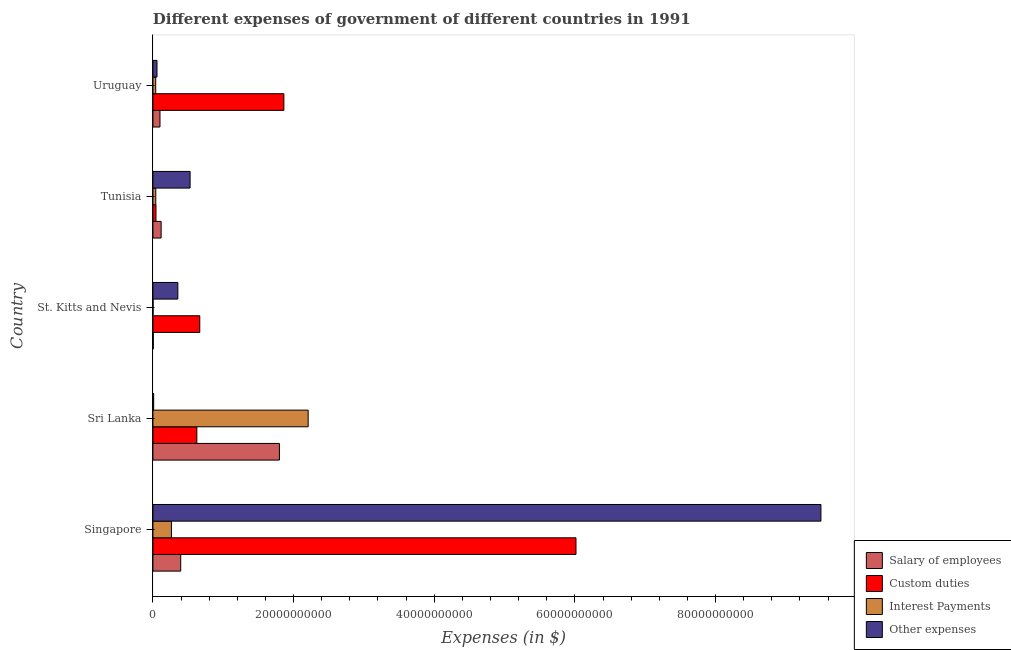How many different coloured bars are there?
Your answer should be very brief. 4. Are the number of bars on each tick of the Y-axis equal?
Your response must be concise. Yes. How many bars are there on the 3rd tick from the top?
Offer a very short reply. 4. How many bars are there on the 3rd tick from the bottom?
Your answer should be compact. 4. What is the label of the 5th group of bars from the top?
Give a very brief answer. Singapore. What is the amount spent on other expenses in St. Kitts and Nevis?
Provide a succinct answer. 3.54e+09. Across all countries, what is the maximum amount spent on custom duties?
Give a very brief answer. 6.02e+1. Across all countries, what is the minimum amount spent on other expenses?
Your answer should be very brief. 1.02e+08. In which country was the amount spent on interest payments maximum?
Offer a very short reply. Sri Lanka. In which country was the amount spent on custom duties minimum?
Your response must be concise. Tunisia. What is the total amount spent on other expenses in the graph?
Offer a very short reply. 1.04e+11. What is the difference between the amount spent on custom duties in Singapore and that in Tunisia?
Your answer should be very brief. 5.97e+1. What is the difference between the amount spent on other expenses in Sri Lanka and the amount spent on salary of employees in Uruguay?
Offer a terse response. -8.99e+08. What is the average amount spent on interest payments per country?
Your answer should be compact. 5.10e+09. What is the difference between the amount spent on custom duties and amount spent on salary of employees in St. Kitts and Nevis?
Offer a very short reply. 6.61e+09. What is the ratio of the amount spent on interest payments in St. Kitts and Nevis to that in Uruguay?
Your answer should be very brief. 0.04. What is the difference between the highest and the second highest amount spent on custom duties?
Your response must be concise. 4.15e+1. What is the difference between the highest and the lowest amount spent on custom duties?
Keep it short and to the point. 5.97e+1. Is the sum of the amount spent on other expenses in Tunisia and Uruguay greater than the maximum amount spent on custom duties across all countries?
Make the answer very short. No. Is it the case that in every country, the sum of the amount spent on custom duties and amount spent on other expenses is greater than the sum of amount spent on interest payments and amount spent on salary of employees?
Your answer should be very brief. No. What does the 2nd bar from the top in St. Kitts and Nevis represents?
Ensure brevity in your answer.  Interest Payments. What does the 3rd bar from the bottom in Tunisia represents?
Provide a short and direct response. Interest Payments. Is it the case that in every country, the sum of the amount spent on salary of employees and amount spent on custom duties is greater than the amount spent on interest payments?
Offer a terse response. Yes. How many countries are there in the graph?
Provide a short and direct response. 5. Does the graph contain grids?
Your answer should be compact. No. How many legend labels are there?
Provide a short and direct response. 4. What is the title of the graph?
Ensure brevity in your answer.  Different expenses of government of different countries in 1991. Does "Korea" appear as one of the legend labels in the graph?
Give a very brief answer. No. What is the label or title of the X-axis?
Provide a succinct answer. Expenses (in $). What is the label or title of the Y-axis?
Your answer should be very brief. Country. What is the Expenses (in $) of Salary of employees in Singapore?
Your answer should be compact. 3.95e+09. What is the Expenses (in $) of Custom duties in Singapore?
Your response must be concise. 6.02e+1. What is the Expenses (in $) in Interest Payments in Singapore?
Provide a succinct answer. 2.63e+09. What is the Expenses (in $) in Other expenses in Singapore?
Offer a very short reply. 9.50e+1. What is the Expenses (in $) in Salary of employees in Sri Lanka?
Your response must be concise. 1.80e+1. What is the Expenses (in $) of Custom duties in Sri Lanka?
Offer a terse response. 6.24e+09. What is the Expenses (in $) in Interest Payments in Sri Lanka?
Give a very brief answer. 2.21e+1. What is the Expenses (in $) of Other expenses in Sri Lanka?
Your answer should be compact. 1.02e+08. What is the Expenses (in $) of Salary of employees in St. Kitts and Nevis?
Your answer should be compact. 5.13e+07. What is the Expenses (in $) in Custom duties in St. Kitts and Nevis?
Make the answer very short. 6.66e+09. What is the Expenses (in $) in Interest Payments in St. Kitts and Nevis?
Ensure brevity in your answer.  1.40e+07. What is the Expenses (in $) in Other expenses in St. Kitts and Nevis?
Your response must be concise. 3.54e+09. What is the Expenses (in $) of Salary of employees in Tunisia?
Your answer should be compact. 1.16e+09. What is the Expenses (in $) of Custom duties in Tunisia?
Your answer should be very brief. 4.33e+08. What is the Expenses (in $) of Interest Payments in Tunisia?
Give a very brief answer. 4.05e+08. What is the Expenses (in $) in Other expenses in Tunisia?
Make the answer very short. 5.28e+09. What is the Expenses (in $) in Salary of employees in Uruguay?
Make the answer very short. 1.00e+09. What is the Expenses (in $) of Custom duties in Uruguay?
Ensure brevity in your answer.  1.86e+1. What is the Expenses (in $) in Interest Payments in Uruguay?
Provide a succinct answer. 3.95e+08. What is the Expenses (in $) of Other expenses in Uruguay?
Provide a short and direct response. 5.77e+08. Across all countries, what is the maximum Expenses (in $) of Salary of employees?
Offer a very short reply. 1.80e+1. Across all countries, what is the maximum Expenses (in $) in Custom duties?
Keep it short and to the point. 6.02e+1. Across all countries, what is the maximum Expenses (in $) of Interest Payments?
Your response must be concise. 2.21e+1. Across all countries, what is the maximum Expenses (in $) of Other expenses?
Make the answer very short. 9.50e+1. Across all countries, what is the minimum Expenses (in $) of Salary of employees?
Make the answer very short. 5.13e+07. Across all countries, what is the minimum Expenses (in $) of Custom duties?
Give a very brief answer. 4.33e+08. Across all countries, what is the minimum Expenses (in $) in Interest Payments?
Make the answer very short. 1.40e+07. Across all countries, what is the minimum Expenses (in $) in Other expenses?
Keep it short and to the point. 1.02e+08. What is the total Expenses (in $) of Salary of employees in the graph?
Your answer should be very brief. 2.42e+1. What is the total Expenses (in $) of Custom duties in the graph?
Your answer should be very brief. 9.21e+1. What is the total Expenses (in $) of Interest Payments in the graph?
Offer a very short reply. 2.55e+1. What is the total Expenses (in $) of Other expenses in the graph?
Provide a succinct answer. 1.04e+11. What is the difference between the Expenses (in $) in Salary of employees in Singapore and that in Sri Lanka?
Your answer should be compact. -1.40e+1. What is the difference between the Expenses (in $) in Custom duties in Singapore and that in Sri Lanka?
Give a very brief answer. 5.39e+1. What is the difference between the Expenses (in $) in Interest Payments in Singapore and that in Sri Lanka?
Keep it short and to the point. -1.94e+1. What is the difference between the Expenses (in $) in Other expenses in Singapore and that in Sri Lanka?
Give a very brief answer. 9.49e+1. What is the difference between the Expenses (in $) of Salary of employees in Singapore and that in St. Kitts and Nevis?
Provide a short and direct response. 3.90e+09. What is the difference between the Expenses (in $) of Custom duties in Singapore and that in St. Kitts and Nevis?
Your answer should be compact. 5.35e+1. What is the difference between the Expenses (in $) of Interest Payments in Singapore and that in St. Kitts and Nevis?
Give a very brief answer. 2.62e+09. What is the difference between the Expenses (in $) of Other expenses in Singapore and that in St. Kitts and Nevis?
Make the answer very short. 9.14e+1. What is the difference between the Expenses (in $) in Salary of employees in Singapore and that in Tunisia?
Your response must be concise. 2.78e+09. What is the difference between the Expenses (in $) of Custom duties in Singapore and that in Tunisia?
Provide a short and direct response. 5.97e+1. What is the difference between the Expenses (in $) in Interest Payments in Singapore and that in Tunisia?
Provide a short and direct response. 2.22e+09. What is the difference between the Expenses (in $) of Other expenses in Singapore and that in Tunisia?
Offer a terse response. 8.97e+1. What is the difference between the Expenses (in $) in Salary of employees in Singapore and that in Uruguay?
Keep it short and to the point. 2.95e+09. What is the difference between the Expenses (in $) in Custom duties in Singapore and that in Uruguay?
Your answer should be compact. 4.15e+1. What is the difference between the Expenses (in $) in Interest Payments in Singapore and that in Uruguay?
Offer a terse response. 2.23e+09. What is the difference between the Expenses (in $) in Other expenses in Singapore and that in Uruguay?
Offer a very short reply. 9.44e+1. What is the difference between the Expenses (in $) in Salary of employees in Sri Lanka and that in St. Kitts and Nevis?
Give a very brief answer. 1.79e+1. What is the difference between the Expenses (in $) of Custom duties in Sri Lanka and that in St. Kitts and Nevis?
Offer a very short reply. -4.14e+08. What is the difference between the Expenses (in $) of Interest Payments in Sri Lanka and that in St. Kitts and Nevis?
Your answer should be very brief. 2.21e+1. What is the difference between the Expenses (in $) in Other expenses in Sri Lanka and that in St. Kitts and Nevis?
Offer a very short reply. -3.44e+09. What is the difference between the Expenses (in $) of Salary of employees in Sri Lanka and that in Tunisia?
Offer a terse response. 1.68e+1. What is the difference between the Expenses (in $) in Custom duties in Sri Lanka and that in Tunisia?
Give a very brief answer. 5.81e+09. What is the difference between the Expenses (in $) of Interest Payments in Sri Lanka and that in Tunisia?
Give a very brief answer. 2.17e+1. What is the difference between the Expenses (in $) of Other expenses in Sri Lanka and that in Tunisia?
Offer a very short reply. -5.18e+09. What is the difference between the Expenses (in $) in Salary of employees in Sri Lanka and that in Uruguay?
Keep it short and to the point. 1.70e+1. What is the difference between the Expenses (in $) in Custom duties in Sri Lanka and that in Uruguay?
Your response must be concise. -1.24e+1. What is the difference between the Expenses (in $) in Interest Payments in Sri Lanka and that in Uruguay?
Your answer should be very brief. 2.17e+1. What is the difference between the Expenses (in $) in Other expenses in Sri Lanka and that in Uruguay?
Ensure brevity in your answer.  -4.75e+08. What is the difference between the Expenses (in $) of Salary of employees in St. Kitts and Nevis and that in Tunisia?
Provide a succinct answer. -1.11e+09. What is the difference between the Expenses (in $) in Custom duties in St. Kitts and Nevis and that in Tunisia?
Your response must be concise. 6.22e+09. What is the difference between the Expenses (in $) in Interest Payments in St. Kitts and Nevis and that in Tunisia?
Your answer should be compact. -3.91e+08. What is the difference between the Expenses (in $) of Other expenses in St. Kitts and Nevis and that in Tunisia?
Your answer should be very brief. -1.74e+09. What is the difference between the Expenses (in $) of Salary of employees in St. Kitts and Nevis and that in Uruguay?
Keep it short and to the point. -9.50e+08. What is the difference between the Expenses (in $) in Custom duties in St. Kitts and Nevis and that in Uruguay?
Provide a short and direct response. -1.20e+1. What is the difference between the Expenses (in $) in Interest Payments in St. Kitts and Nevis and that in Uruguay?
Give a very brief answer. -3.81e+08. What is the difference between the Expenses (in $) in Other expenses in St. Kitts and Nevis and that in Uruguay?
Keep it short and to the point. 2.96e+09. What is the difference between the Expenses (in $) of Salary of employees in Tunisia and that in Uruguay?
Make the answer very short. 1.64e+08. What is the difference between the Expenses (in $) of Custom duties in Tunisia and that in Uruguay?
Ensure brevity in your answer.  -1.82e+1. What is the difference between the Expenses (in $) in Interest Payments in Tunisia and that in Uruguay?
Your answer should be compact. 1.00e+07. What is the difference between the Expenses (in $) of Other expenses in Tunisia and that in Uruguay?
Your response must be concise. 4.70e+09. What is the difference between the Expenses (in $) of Salary of employees in Singapore and the Expenses (in $) of Custom duties in Sri Lanka?
Your answer should be very brief. -2.29e+09. What is the difference between the Expenses (in $) in Salary of employees in Singapore and the Expenses (in $) in Interest Payments in Sri Lanka?
Give a very brief answer. -1.81e+1. What is the difference between the Expenses (in $) in Salary of employees in Singapore and the Expenses (in $) in Other expenses in Sri Lanka?
Your answer should be compact. 3.85e+09. What is the difference between the Expenses (in $) of Custom duties in Singapore and the Expenses (in $) of Interest Payments in Sri Lanka?
Your answer should be compact. 3.81e+1. What is the difference between the Expenses (in $) of Custom duties in Singapore and the Expenses (in $) of Other expenses in Sri Lanka?
Offer a terse response. 6.01e+1. What is the difference between the Expenses (in $) in Interest Payments in Singapore and the Expenses (in $) in Other expenses in Sri Lanka?
Your answer should be very brief. 2.53e+09. What is the difference between the Expenses (in $) in Salary of employees in Singapore and the Expenses (in $) in Custom duties in St. Kitts and Nevis?
Provide a short and direct response. -2.71e+09. What is the difference between the Expenses (in $) of Salary of employees in Singapore and the Expenses (in $) of Interest Payments in St. Kitts and Nevis?
Provide a succinct answer. 3.94e+09. What is the difference between the Expenses (in $) of Salary of employees in Singapore and the Expenses (in $) of Other expenses in St. Kitts and Nevis?
Your response must be concise. 4.08e+08. What is the difference between the Expenses (in $) of Custom duties in Singapore and the Expenses (in $) of Interest Payments in St. Kitts and Nevis?
Offer a very short reply. 6.01e+1. What is the difference between the Expenses (in $) in Custom duties in Singapore and the Expenses (in $) in Other expenses in St. Kitts and Nevis?
Ensure brevity in your answer.  5.66e+1. What is the difference between the Expenses (in $) in Interest Payments in Singapore and the Expenses (in $) in Other expenses in St. Kitts and Nevis?
Keep it short and to the point. -9.12e+08. What is the difference between the Expenses (in $) in Salary of employees in Singapore and the Expenses (in $) in Custom duties in Tunisia?
Your answer should be very brief. 3.52e+09. What is the difference between the Expenses (in $) of Salary of employees in Singapore and the Expenses (in $) of Interest Payments in Tunisia?
Provide a short and direct response. 3.54e+09. What is the difference between the Expenses (in $) in Salary of employees in Singapore and the Expenses (in $) in Other expenses in Tunisia?
Make the answer very short. -1.33e+09. What is the difference between the Expenses (in $) of Custom duties in Singapore and the Expenses (in $) of Interest Payments in Tunisia?
Provide a short and direct response. 5.98e+1. What is the difference between the Expenses (in $) of Custom duties in Singapore and the Expenses (in $) of Other expenses in Tunisia?
Provide a succinct answer. 5.49e+1. What is the difference between the Expenses (in $) in Interest Payments in Singapore and the Expenses (in $) in Other expenses in Tunisia?
Make the answer very short. -2.65e+09. What is the difference between the Expenses (in $) in Salary of employees in Singapore and the Expenses (in $) in Custom duties in Uruguay?
Ensure brevity in your answer.  -1.47e+1. What is the difference between the Expenses (in $) in Salary of employees in Singapore and the Expenses (in $) in Interest Payments in Uruguay?
Provide a succinct answer. 3.55e+09. What is the difference between the Expenses (in $) of Salary of employees in Singapore and the Expenses (in $) of Other expenses in Uruguay?
Give a very brief answer. 3.37e+09. What is the difference between the Expenses (in $) in Custom duties in Singapore and the Expenses (in $) in Interest Payments in Uruguay?
Give a very brief answer. 5.98e+1. What is the difference between the Expenses (in $) in Custom duties in Singapore and the Expenses (in $) in Other expenses in Uruguay?
Give a very brief answer. 5.96e+1. What is the difference between the Expenses (in $) of Interest Payments in Singapore and the Expenses (in $) of Other expenses in Uruguay?
Provide a short and direct response. 2.05e+09. What is the difference between the Expenses (in $) in Salary of employees in Sri Lanka and the Expenses (in $) in Custom duties in St. Kitts and Nevis?
Your answer should be very brief. 1.13e+1. What is the difference between the Expenses (in $) of Salary of employees in Sri Lanka and the Expenses (in $) of Interest Payments in St. Kitts and Nevis?
Your response must be concise. 1.80e+1. What is the difference between the Expenses (in $) in Salary of employees in Sri Lanka and the Expenses (in $) in Other expenses in St. Kitts and Nevis?
Offer a very short reply. 1.44e+1. What is the difference between the Expenses (in $) in Custom duties in Sri Lanka and the Expenses (in $) in Interest Payments in St. Kitts and Nevis?
Your answer should be very brief. 6.23e+09. What is the difference between the Expenses (in $) of Custom duties in Sri Lanka and the Expenses (in $) of Other expenses in St. Kitts and Nevis?
Give a very brief answer. 2.70e+09. What is the difference between the Expenses (in $) of Interest Payments in Sri Lanka and the Expenses (in $) of Other expenses in St. Kitts and Nevis?
Offer a very short reply. 1.85e+1. What is the difference between the Expenses (in $) of Salary of employees in Sri Lanka and the Expenses (in $) of Custom duties in Tunisia?
Ensure brevity in your answer.  1.76e+1. What is the difference between the Expenses (in $) of Salary of employees in Sri Lanka and the Expenses (in $) of Interest Payments in Tunisia?
Make the answer very short. 1.76e+1. What is the difference between the Expenses (in $) of Salary of employees in Sri Lanka and the Expenses (in $) of Other expenses in Tunisia?
Offer a terse response. 1.27e+1. What is the difference between the Expenses (in $) of Custom duties in Sri Lanka and the Expenses (in $) of Interest Payments in Tunisia?
Give a very brief answer. 5.84e+09. What is the difference between the Expenses (in $) of Custom duties in Sri Lanka and the Expenses (in $) of Other expenses in Tunisia?
Provide a succinct answer. 9.61e+08. What is the difference between the Expenses (in $) of Interest Payments in Sri Lanka and the Expenses (in $) of Other expenses in Tunisia?
Provide a succinct answer. 1.68e+1. What is the difference between the Expenses (in $) of Salary of employees in Sri Lanka and the Expenses (in $) of Custom duties in Uruguay?
Keep it short and to the point. -6.32e+08. What is the difference between the Expenses (in $) of Salary of employees in Sri Lanka and the Expenses (in $) of Interest Payments in Uruguay?
Provide a succinct answer. 1.76e+1. What is the difference between the Expenses (in $) in Salary of employees in Sri Lanka and the Expenses (in $) in Other expenses in Uruguay?
Offer a terse response. 1.74e+1. What is the difference between the Expenses (in $) in Custom duties in Sri Lanka and the Expenses (in $) in Interest Payments in Uruguay?
Give a very brief answer. 5.85e+09. What is the difference between the Expenses (in $) of Custom duties in Sri Lanka and the Expenses (in $) of Other expenses in Uruguay?
Provide a succinct answer. 5.67e+09. What is the difference between the Expenses (in $) in Interest Payments in Sri Lanka and the Expenses (in $) in Other expenses in Uruguay?
Provide a short and direct response. 2.15e+1. What is the difference between the Expenses (in $) in Salary of employees in St. Kitts and Nevis and the Expenses (in $) in Custom duties in Tunisia?
Keep it short and to the point. -3.82e+08. What is the difference between the Expenses (in $) in Salary of employees in St. Kitts and Nevis and the Expenses (in $) in Interest Payments in Tunisia?
Offer a terse response. -3.54e+08. What is the difference between the Expenses (in $) of Salary of employees in St. Kitts and Nevis and the Expenses (in $) of Other expenses in Tunisia?
Your answer should be very brief. -5.23e+09. What is the difference between the Expenses (in $) of Custom duties in St. Kitts and Nevis and the Expenses (in $) of Interest Payments in Tunisia?
Your answer should be very brief. 6.25e+09. What is the difference between the Expenses (in $) in Custom duties in St. Kitts and Nevis and the Expenses (in $) in Other expenses in Tunisia?
Your response must be concise. 1.38e+09. What is the difference between the Expenses (in $) in Interest Payments in St. Kitts and Nevis and the Expenses (in $) in Other expenses in Tunisia?
Provide a succinct answer. -5.27e+09. What is the difference between the Expenses (in $) of Salary of employees in St. Kitts and Nevis and the Expenses (in $) of Custom duties in Uruguay?
Offer a terse response. -1.86e+1. What is the difference between the Expenses (in $) in Salary of employees in St. Kitts and Nevis and the Expenses (in $) in Interest Payments in Uruguay?
Make the answer very short. -3.44e+08. What is the difference between the Expenses (in $) of Salary of employees in St. Kitts and Nevis and the Expenses (in $) of Other expenses in Uruguay?
Offer a very short reply. -5.26e+08. What is the difference between the Expenses (in $) of Custom duties in St. Kitts and Nevis and the Expenses (in $) of Interest Payments in Uruguay?
Ensure brevity in your answer.  6.26e+09. What is the difference between the Expenses (in $) in Custom duties in St. Kitts and Nevis and the Expenses (in $) in Other expenses in Uruguay?
Give a very brief answer. 6.08e+09. What is the difference between the Expenses (in $) of Interest Payments in St. Kitts and Nevis and the Expenses (in $) of Other expenses in Uruguay?
Your answer should be very brief. -5.63e+08. What is the difference between the Expenses (in $) of Salary of employees in Tunisia and the Expenses (in $) of Custom duties in Uruguay?
Ensure brevity in your answer.  -1.75e+1. What is the difference between the Expenses (in $) of Salary of employees in Tunisia and the Expenses (in $) of Interest Payments in Uruguay?
Your answer should be compact. 7.70e+08. What is the difference between the Expenses (in $) in Salary of employees in Tunisia and the Expenses (in $) in Other expenses in Uruguay?
Keep it short and to the point. 5.88e+08. What is the difference between the Expenses (in $) of Custom duties in Tunisia and the Expenses (in $) of Interest Payments in Uruguay?
Provide a succinct answer. 3.80e+07. What is the difference between the Expenses (in $) of Custom duties in Tunisia and the Expenses (in $) of Other expenses in Uruguay?
Keep it short and to the point. -1.44e+08. What is the difference between the Expenses (in $) of Interest Payments in Tunisia and the Expenses (in $) of Other expenses in Uruguay?
Your response must be concise. -1.72e+08. What is the average Expenses (in $) in Salary of employees per country?
Offer a terse response. 4.83e+09. What is the average Expenses (in $) of Custom duties per country?
Your answer should be very brief. 1.84e+1. What is the average Expenses (in $) of Interest Payments per country?
Give a very brief answer. 5.10e+09. What is the average Expenses (in $) in Other expenses per country?
Your response must be concise. 2.09e+1. What is the difference between the Expenses (in $) in Salary of employees and Expenses (in $) in Custom duties in Singapore?
Offer a very short reply. -5.62e+1. What is the difference between the Expenses (in $) of Salary of employees and Expenses (in $) of Interest Payments in Singapore?
Your answer should be compact. 1.32e+09. What is the difference between the Expenses (in $) of Salary of employees and Expenses (in $) of Other expenses in Singapore?
Make the answer very short. -9.10e+1. What is the difference between the Expenses (in $) of Custom duties and Expenses (in $) of Interest Payments in Singapore?
Keep it short and to the point. 5.75e+1. What is the difference between the Expenses (in $) of Custom duties and Expenses (in $) of Other expenses in Singapore?
Your answer should be compact. -3.48e+1. What is the difference between the Expenses (in $) of Interest Payments and Expenses (in $) of Other expenses in Singapore?
Ensure brevity in your answer.  -9.24e+1. What is the difference between the Expenses (in $) of Salary of employees and Expenses (in $) of Custom duties in Sri Lanka?
Keep it short and to the point. 1.17e+1. What is the difference between the Expenses (in $) in Salary of employees and Expenses (in $) in Interest Payments in Sri Lanka?
Provide a succinct answer. -4.09e+09. What is the difference between the Expenses (in $) of Salary of employees and Expenses (in $) of Other expenses in Sri Lanka?
Keep it short and to the point. 1.79e+1. What is the difference between the Expenses (in $) in Custom duties and Expenses (in $) in Interest Payments in Sri Lanka?
Your answer should be compact. -1.58e+1. What is the difference between the Expenses (in $) of Custom duties and Expenses (in $) of Other expenses in Sri Lanka?
Provide a succinct answer. 6.14e+09. What is the difference between the Expenses (in $) in Interest Payments and Expenses (in $) in Other expenses in Sri Lanka?
Ensure brevity in your answer.  2.20e+1. What is the difference between the Expenses (in $) in Salary of employees and Expenses (in $) in Custom duties in St. Kitts and Nevis?
Offer a terse response. -6.61e+09. What is the difference between the Expenses (in $) in Salary of employees and Expenses (in $) in Interest Payments in St. Kitts and Nevis?
Your response must be concise. 3.73e+07. What is the difference between the Expenses (in $) of Salary of employees and Expenses (in $) of Other expenses in St. Kitts and Nevis?
Your response must be concise. -3.49e+09. What is the difference between the Expenses (in $) in Custom duties and Expenses (in $) in Interest Payments in St. Kitts and Nevis?
Your answer should be compact. 6.64e+09. What is the difference between the Expenses (in $) of Custom duties and Expenses (in $) of Other expenses in St. Kitts and Nevis?
Provide a short and direct response. 3.12e+09. What is the difference between the Expenses (in $) in Interest Payments and Expenses (in $) in Other expenses in St. Kitts and Nevis?
Offer a terse response. -3.53e+09. What is the difference between the Expenses (in $) in Salary of employees and Expenses (in $) in Custom duties in Tunisia?
Keep it short and to the point. 7.32e+08. What is the difference between the Expenses (in $) in Salary of employees and Expenses (in $) in Interest Payments in Tunisia?
Provide a short and direct response. 7.60e+08. What is the difference between the Expenses (in $) in Salary of employees and Expenses (in $) in Other expenses in Tunisia?
Provide a succinct answer. -4.12e+09. What is the difference between the Expenses (in $) in Custom duties and Expenses (in $) in Interest Payments in Tunisia?
Make the answer very short. 2.80e+07. What is the difference between the Expenses (in $) in Custom duties and Expenses (in $) in Other expenses in Tunisia?
Make the answer very short. -4.85e+09. What is the difference between the Expenses (in $) in Interest Payments and Expenses (in $) in Other expenses in Tunisia?
Give a very brief answer. -4.88e+09. What is the difference between the Expenses (in $) in Salary of employees and Expenses (in $) in Custom duties in Uruguay?
Make the answer very short. -1.76e+1. What is the difference between the Expenses (in $) in Salary of employees and Expenses (in $) in Interest Payments in Uruguay?
Provide a succinct answer. 6.06e+08. What is the difference between the Expenses (in $) in Salary of employees and Expenses (in $) in Other expenses in Uruguay?
Give a very brief answer. 4.24e+08. What is the difference between the Expenses (in $) of Custom duties and Expenses (in $) of Interest Payments in Uruguay?
Ensure brevity in your answer.  1.82e+1. What is the difference between the Expenses (in $) in Custom duties and Expenses (in $) in Other expenses in Uruguay?
Provide a succinct answer. 1.80e+1. What is the difference between the Expenses (in $) in Interest Payments and Expenses (in $) in Other expenses in Uruguay?
Offer a very short reply. -1.82e+08. What is the ratio of the Expenses (in $) in Salary of employees in Singapore to that in Sri Lanka?
Give a very brief answer. 0.22. What is the ratio of the Expenses (in $) of Custom duties in Singapore to that in Sri Lanka?
Offer a very short reply. 9.64. What is the ratio of the Expenses (in $) in Interest Payments in Singapore to that in Sri Lanka?
Offer a terse response. 0.12. What is the ratio of the Expenses (in $) in Other expenses in Singapore to that in Sri Lanka?
Offer a very short reply. 929.89. What is the ratio of the Expenses (in $) of Salary of employees in Singapore to that in St. Kitts and Nevis?
Provide a short and direct response. 77.01. What is the ratio of the Expenses (in $) in Custom duties in Singapore to that in St. Kitts and Nevis?
Your answer should be compact. 9.04. What is the ratio of the Expenses (in $) of Interest Payments in Singapore to that in St. Kitts and Nevis?
Keep it short and to the point. 188.19. What is the ratio of the Expenses (in $) of Other expenses in Singapore to that in St. Kitts and Nevis?
Provide a succinct answer. 26.82. What is the ratio of the Expenses (in $) in Salary of employees in Singapore to that in Tunisia?
Provide a short and direct response. 3.39. What is the ratio of the Expenses (in $) of Custom duties in Singapore to that in Tunisia?
Offer a very short reply. 138.93. What is the ratio of the Expenses (in $) of Interest Payments in Singapore to that in Tunisia?
Offer a terse response. 6.49. What is the ratio of the Expenses (in $) of Other expenses in Singapore to that in Tunisia?
Give a very brief answer. 17.98. What is the ratio of the Expenses (in $) in Salary of employees in Singapore to that in Uruguay?
Keep it short and to the point. 3.95. What is the ratio of the Expenses (in $) in Custom duties in Singapore to that in Uruguay?
Give a very brief answer. 3.23. What is the ratio of the Expenses (in $) of Interest Payments in Singapore to that in Uruguay?
Ensure brevity in your answer.  6.66. What is the ratio of the Expenses (in $) in Other expenses in Singapore to that in Uruguay?
Provide a short and direct response. 164.59. What is the ratio of the Expenses (in $) in Salary of employees in Sri Lanka to that in St. Kitts and Nevis?
Provide a succinct answer. 350.72. What is the ratio of the Expenses (in $) of Custom duties in Sri Lanka to that in St. Kitts and Nevis?
Provide a short and direct response. 0.94. What is the ratio of the Expenses (in $) in Interest Payments in Sri Lanka to that in St. Kitts and Nevis?
Offer a terse response. 1580.03. What is the ratio of the Expenses (in $) in Other expenses in Sri Lanka to that in St. Kitts and Nevis?
Provide a succinct answer. 0.03. What is the ratio of the Expenses (in $) of Salary of employees in Sri Lanka to that in Tunisia?
Make the answer very short. 15.44. What is the ratio of the Expenses (in $) of Custom duties in Sri Lanka to that in Tunisia?
Offer a terse response. 14.42. What is the ratio of the Expenses (in $) in Interest Payments in Sri Lanka to that in Tunisia?
Your response must be concise. 54.5. What is the ratio of the Expenses (in $) in Other expenses in Sri Lanka to that in Tunisia?
Provide a succinct answer. 0.02. What is the ratio of the Expenses (in $) in Salary of employees in Sri Lanka to that in Uruguay?
Offer a very short reply. 17.97. What is the ratio of the Expenses (in $) in Custom duties in Sri Lanka to that in Uruguay?
Offer a very short reply. 0.34. What is the ratio of the Expenses (in $) of Interest Payments in Sri Lanka to that in Uruguay?
Offer a terse response. 55.88. What is the ratio of the Expenses (in $) of Other expenses in Sri Lanka to that in Uruguay?
Provide a short and direct response. 0.18. What is the ratio of the Expenses (in $) in Salary of employees in St. Kitts and Nevis to that in Tunisia?
Provide a short and direct response. 0.04. What is the ratio of the Expenses (in $) of Custom duties in St. Kitts and Nevis to that in Tunisia?
Offer a very short reply. 15.37. What is the ratio of the Expenses (in $) in Interest Payments in St. Kitts and Nevis to that in Tunisia?
Give a very brief answer. 0.03. What is the ratio of the Expenses (in $) of Other expenses in St. Kitts and Nevis to that in Tunisia?
Offer a terse response. 0.67. What is the ratio of the Expenses (in $) in Salary of employees in St. Kitts and Nevis to that in Uruguay?
Your answer should be compact. 0.05. What is the ratio of the Expenses (in $) in Custom duties in St. Kitts and Nevis to that in Uruguay?
Give a very brief answer. 0.36. What is the ratio of the Expenses (in $) of Interest Payments in St. Kitts and Nevis to that in Uruguay?
Your response must be concise. 0.04. What is the ratio of the Expenses (in $) of Other expenses in St. Kitts and Nevis to that in Uruguay?
Give a very brief answer. 6.14. What is the ratio of the Expenses (in $) in Salary of employees in Tunisia to that in Uruguay?
Offer a terse response. 1.16. What is the ratio of the Expenses (in $) in Custom duties in Tunisia to that in Uruguay?
Provide a succinct answer. 0.02. What is the ratio of the Expenses (in $) in Interest Payments in Tunisia to that in Uruguay?
Your response must be concise. 1.03. What is the ratio of the Expenses (in $) in Other expenses in Tunisia to that in Uruguay?
Provide a succinct answer. 9.15. What is the difference between the highest and the second highest Expenses (in $) in Salary of employees?
Offer a terse response. 1.40e+1. What is the difference between the highest and the second highest Expenses (in $) in Custom duties?
Provide a succinct answer. 4.15e+1. What is the difference between the highest and the second highest Expenses (in $) of Interest Payments?
Your answer should be very brief. 1.94e+1. What is the difference between the highest and the second highest Expenses (in $) in Other expenses?
Offer a very short reply. 8.97e+1. What is the difference between the highest and the lowest Expenses (in $) in Salary of employees?
Provide a succinct answer. 1.79e+1. What is the difference between the highest and the lowest Expenses (in $) in Custom duties?
Offer a terse response. 5.97e+1. What is the difference between the highest and the lowest Expenses (in $) in Interest Payments?
Your response must be concise. 2.21e+1. What is the difference between the highest and the lowest Expenses (in $) in Other expenses?
Your response must be concise. 9.49e+1. 